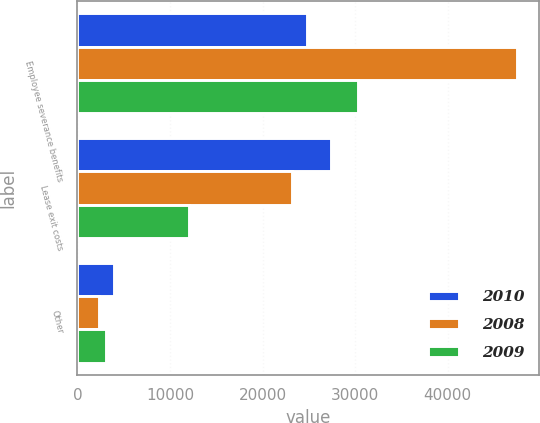Convert chart. <chart><loc_0><loc_0><loc_500><loc_500><stacked_bar_chart><ecel><fcel>Employee severance benefits<fcel>Lease exit costs<fcel>Other<nl><fcel>2010<fcel>24850<fcel>27356<fcel>3929<nl><fcel>2008<fcel>47525<fcel>23208<fcel>2283<nl><fcel>2009<fcel>30343<fcel>12095<fcel>3069<nl></chart> 